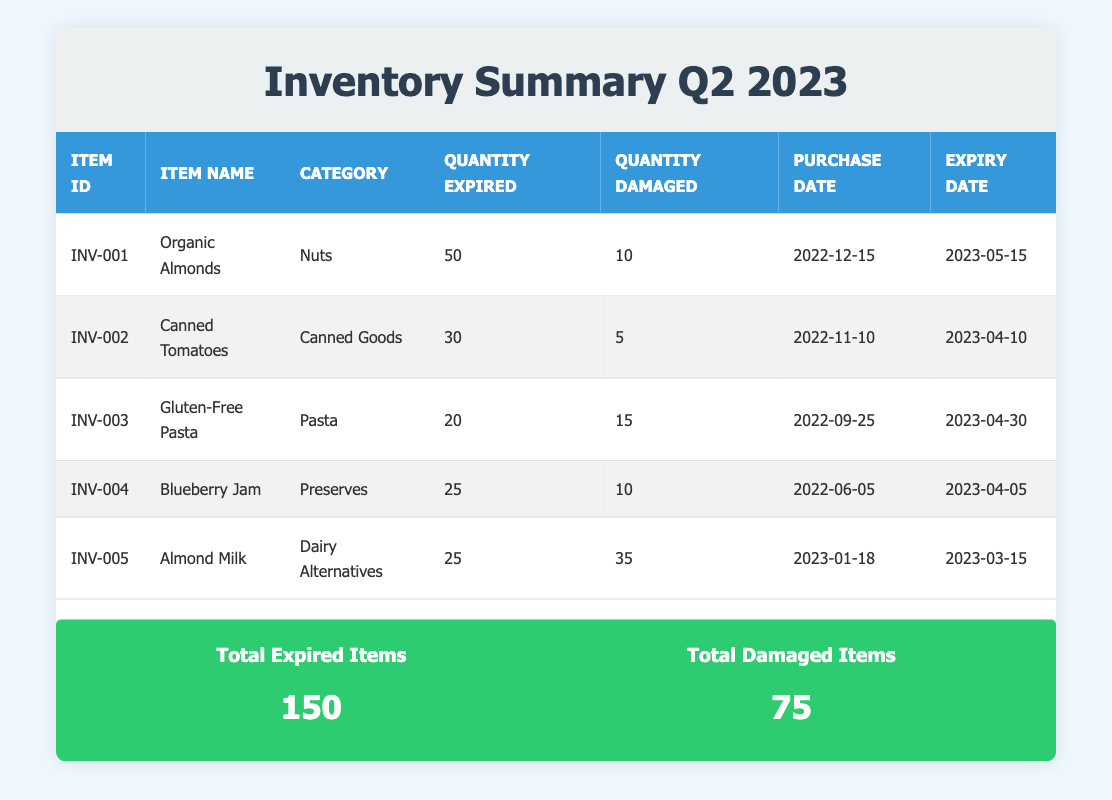What is the total quantity of expired items? The total expired items are mentioned in the summary section of the table. It states that there are 150 total expired items.
Answer: 150 What is the item category for "Almond Milk"? To find the category for "Almond Milk", I look at the corresponding row in the table where "Almond Milk" is listed. It shows that its category is "Dairy Alternatives".
Answer: Dairy Alternatives How many items have a quantity of damaged items greater than 10? I need to review each item’s quantity damaged in the table. The items are: Gluten-Free Pasta (15), Almond Milk (35), and Organic Almonds (10). The counts greater than 10 are Gluten-Free Pasta and Almond Milk. Thus, there are 2 items.
Answer: 2 What is the total number of damaged items across all listed inventory? To find the total number of damaged items, I sum up the quantity damaged for each item: (10 + 5 + 15 + 10 + 35) = 75. The total number of damaged items is 75.
Answer: 75 Did "Canned Tomatoes" expire before its purchase date? I will compare the expiry date of "Canned Tomatoes" (April 10, 2023) with its purchase date (November 10, 2022). Since the expiry date comes after the purchase date, "Canned Tomatoes" did not expire before its purchase date.
Answer: No What is the average quantity of expired items per inventory item? There are 5 items listed in the inventory, and the total quantity of expired items is 150. To calculate the average, I divide 150 by 5, which gives us 30.
Answer: 30 Which item had the earliest purchase date? By reviewing the purchase dates in the table, I find that "Blueberry Jam" was purchased on June 5, 2022, which is earlier than all other items.
Answer: Blueberry Jam How many items had the same quantity of expired items? I can check the quantity expired for each item: Organic Almonds (50), Canned Tomatoes (30), Gluten-Free Pasta (20), Blueberry Jam (25), and Almond Milk (25). "Blueberry Jam" and "Almond Milk" both have a quantity expired of 25. Thus, there are 2 items with the same quantity of expired items.
Answer: 2 What percentage of total inventory items were damaged? There are 5 items listed in total. The quantity damaged is 75. To find the percentage, I need to calculate (75 / total quantity for all items). First, I total the quantity of each item: (50 + 30 + 20 + 25 + 25 = 150). Then, (75 / 150) × 100 = 50%.
Answer: 50% 